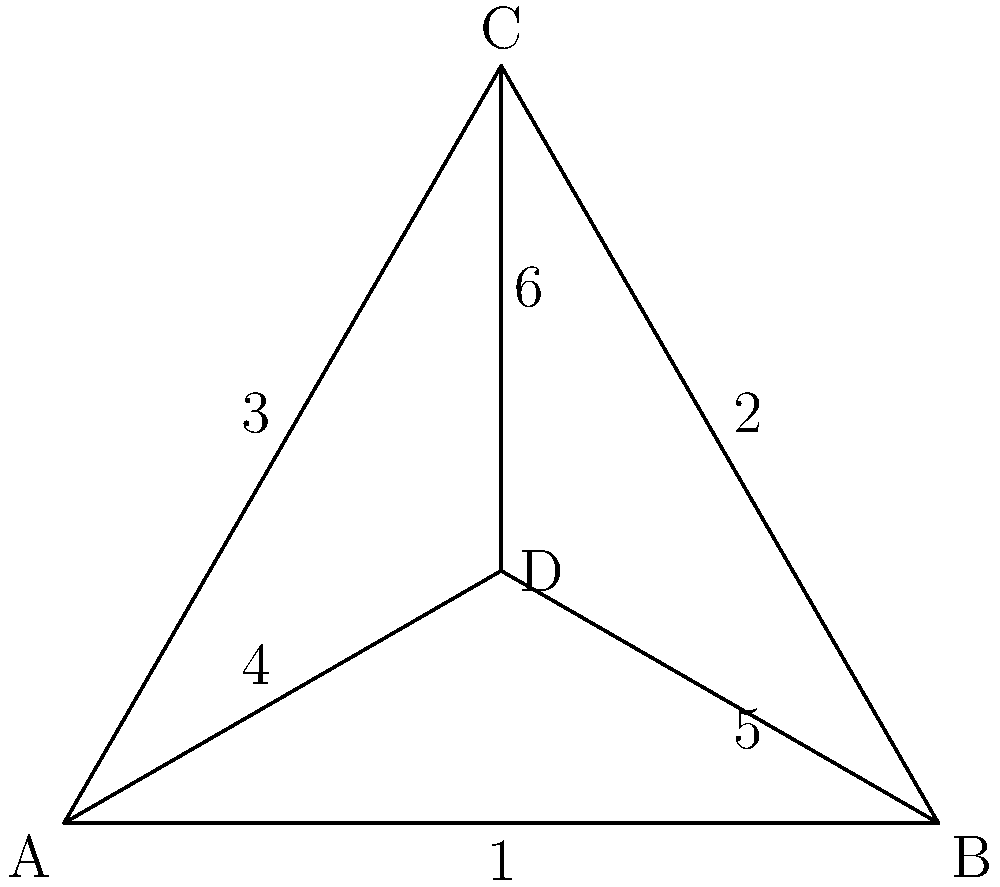Consider the simplified map of spice-producing regions represented by the graph above. Each vertex represents a region, and each edge represents a possible trade route. The group of symmetries of this graph forms a group under composition. What is the order of this group? To determine the order of the symmetry group, we need to count all the symmetries of the graph:

1. Identity symmetry: Always present, keeps the graph unchanged.

2. Rotational symmetries:
   - 120° clockwise rotation around the center
   - 240° clockwise rotation around the center

3. Reflection symmetries:
   - Reflection across the line AD
   - Reflection across the line from B to the midpoint of AC
   - Reflection across the line from C to the midpoint of AB

Therefore, we have:
1 identity symmetry
+ 2 rotational symmetries
+ 3 reflection symmetries
= 6 total symmetries

The order of a group is the number of elements in the group. In this case, each symmetry corresponds to an element in the group.
Answer: 6 